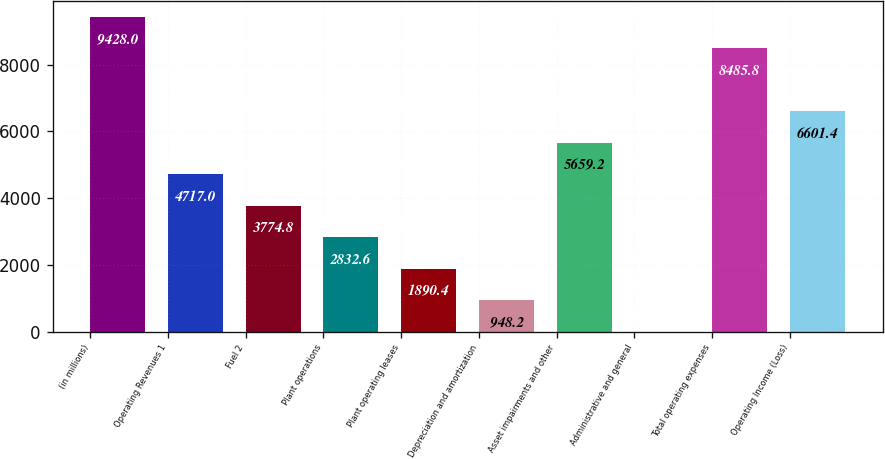Convert chart. <chart><loc_0><loc_0><loc_500><loc_500><bar_chart><fcel>(in millions)<fcel>Operating Revenues 1<fcel>Fuel 2<fcel>Plant operations<fcel>Plant operating leases<fcel>Depreciation and amortization<fcel>Asset impairments and other<fcel>Administrative and general<fcel>Total operating expenses<fcel>Operating Income (Loss)<nl><fcel>9428<fcel>4717<fcel>3774.8<fcel>2832.6<fcel>1890.4<fcel>948.2<fcel>5659.2<fcel>6<fcel>8485.8<fcel>6601.4<nl></chart> 